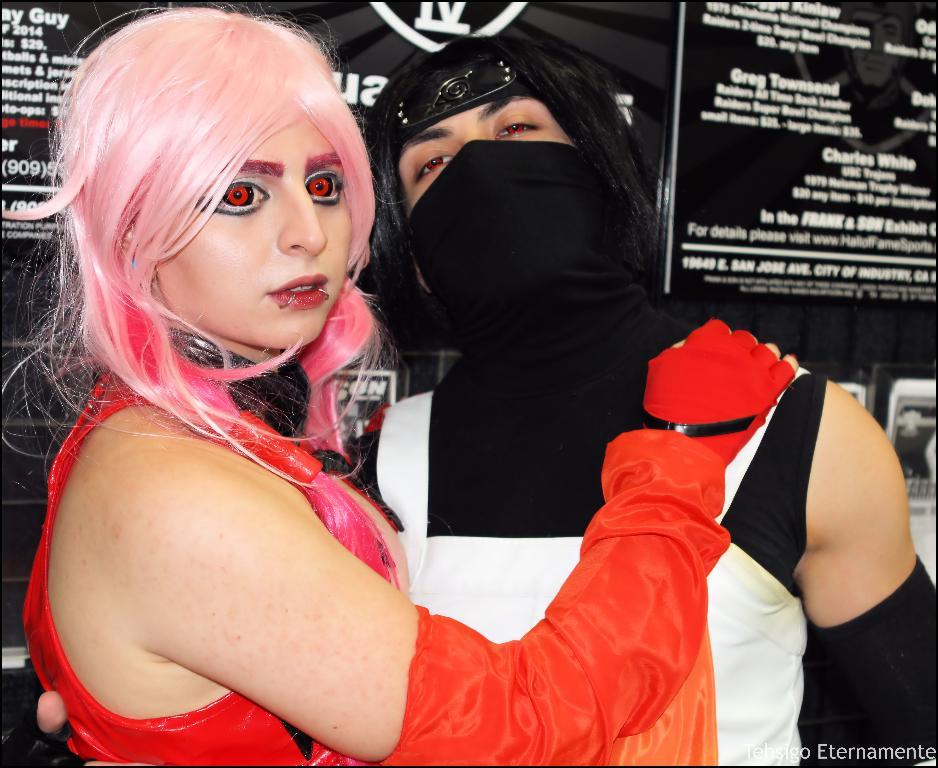<image>
Summarize the visual content of the image. The word Guy is to the left of a woman with pink hair and red eyes. 